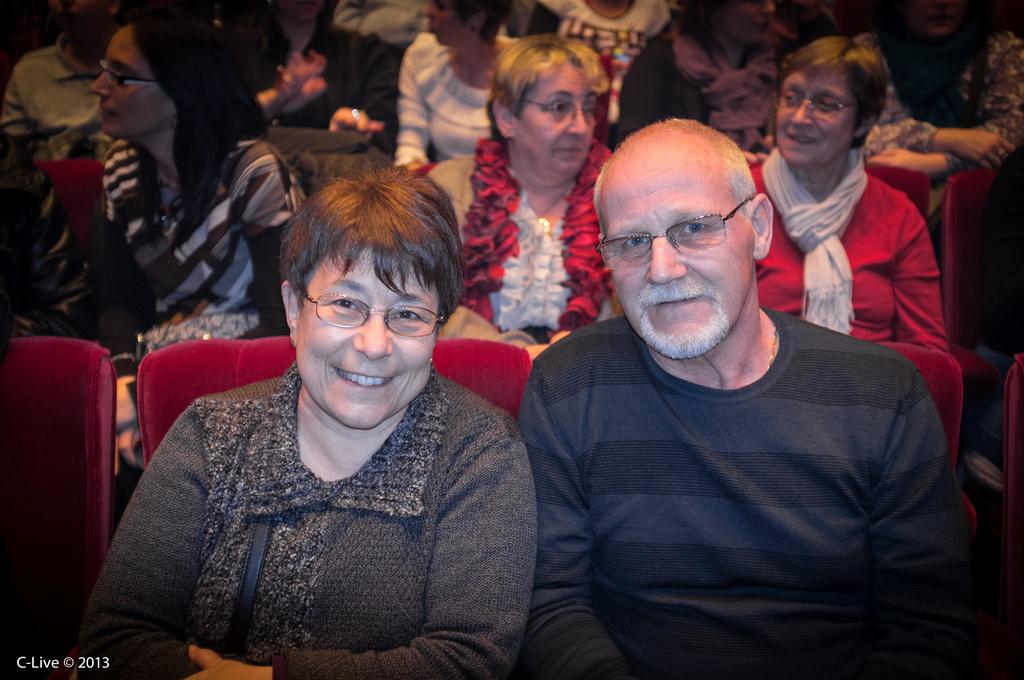How many people are in the image? There are many people in the image. What are the people wearing? The people are wearing clothes. What are the people doing in the image? The people are sitting on chairs and smiling. What can be seen on the faces of the people? The people are wearing spectacles. What type of road can be seen in the image? There is no road present in the image. How many bulbs are visible in the image? There are no bulbs visible in the image. 